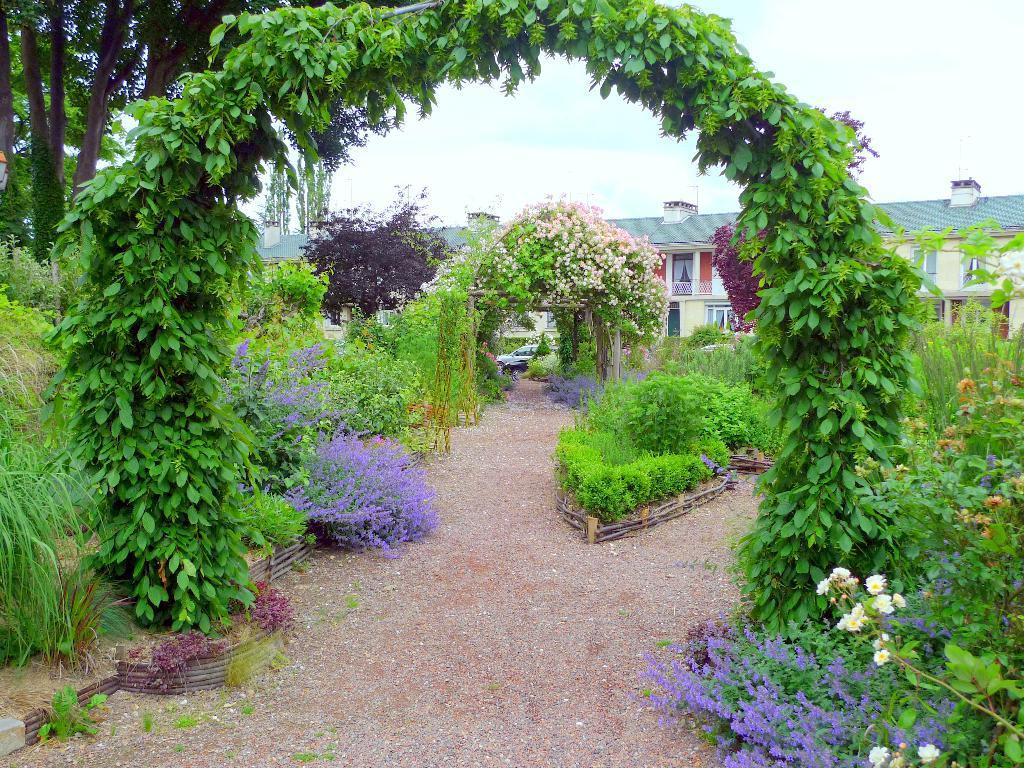What can be seen running through the image? There is a path in the image. What type of vegetation is present in the image? There are plants and trees in the image. What is visible in the background of the image? There is a building in the background of the image. What part of the natural environment is visible in the image? The sky is visible in the image. What mode of transportation can be seen in the image? There is a car in the image. How many donkeys are present in the image? There are no donkeys present in the image. What type of pollution can be seen in the image? There is no pollution visible in the image. 